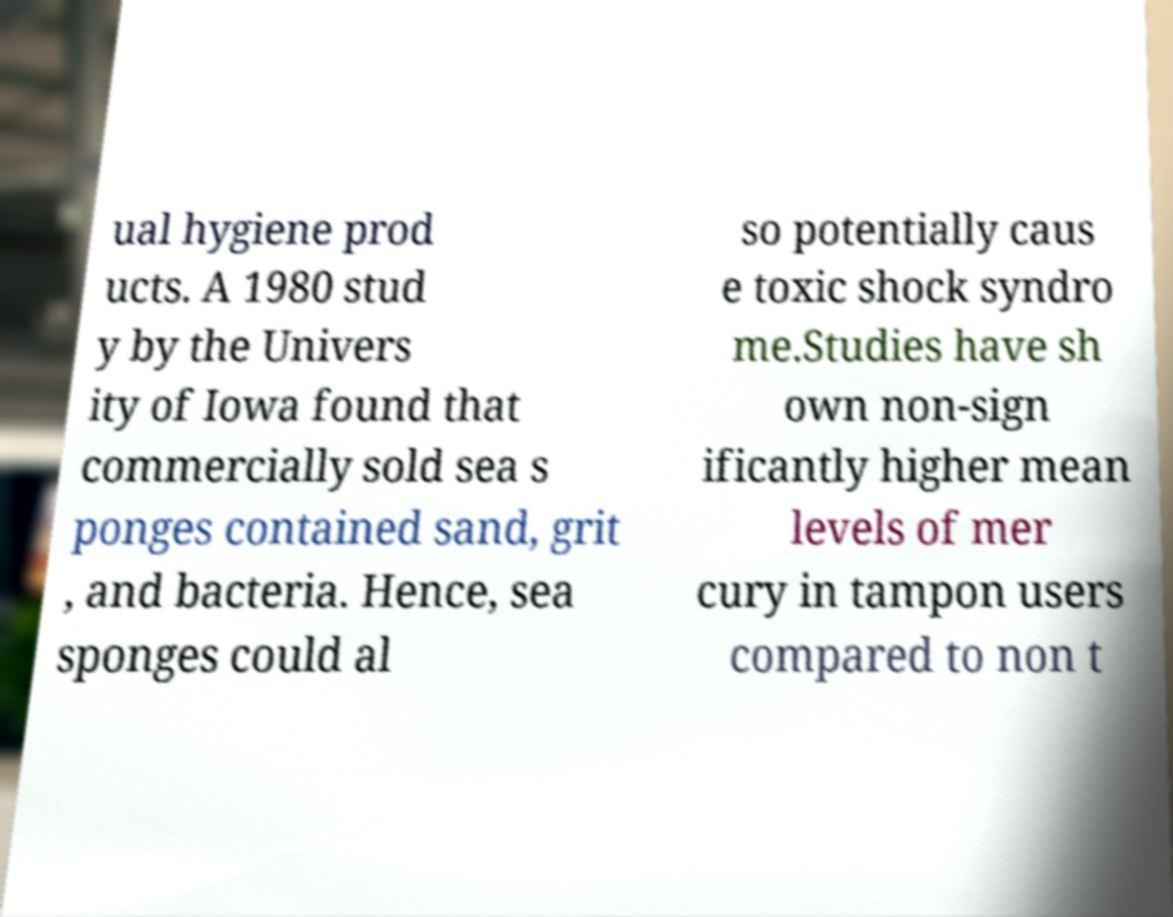Could you assist in decoding the text presented in this image and type it out clearly? ual hygiene prod ucts. A 1980 stud y by the Univers ity of Iowa found that commercially sold sea s ponges contained sand, grit , and bacteria. Hence, sea sponges could al so potentially caus e toxic shock syndro me.Studies have sh own non-sign ificantly higher mean levels of mer cury in tampon users compared to non t 